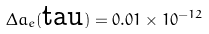<formula> <loc_0><loc_0><loc_500><loc_500>\Delta a _ { e } ( \text {tau} ) = 0 . 0 1 \times 1 0 ^ { - 1 2 }</formula> 